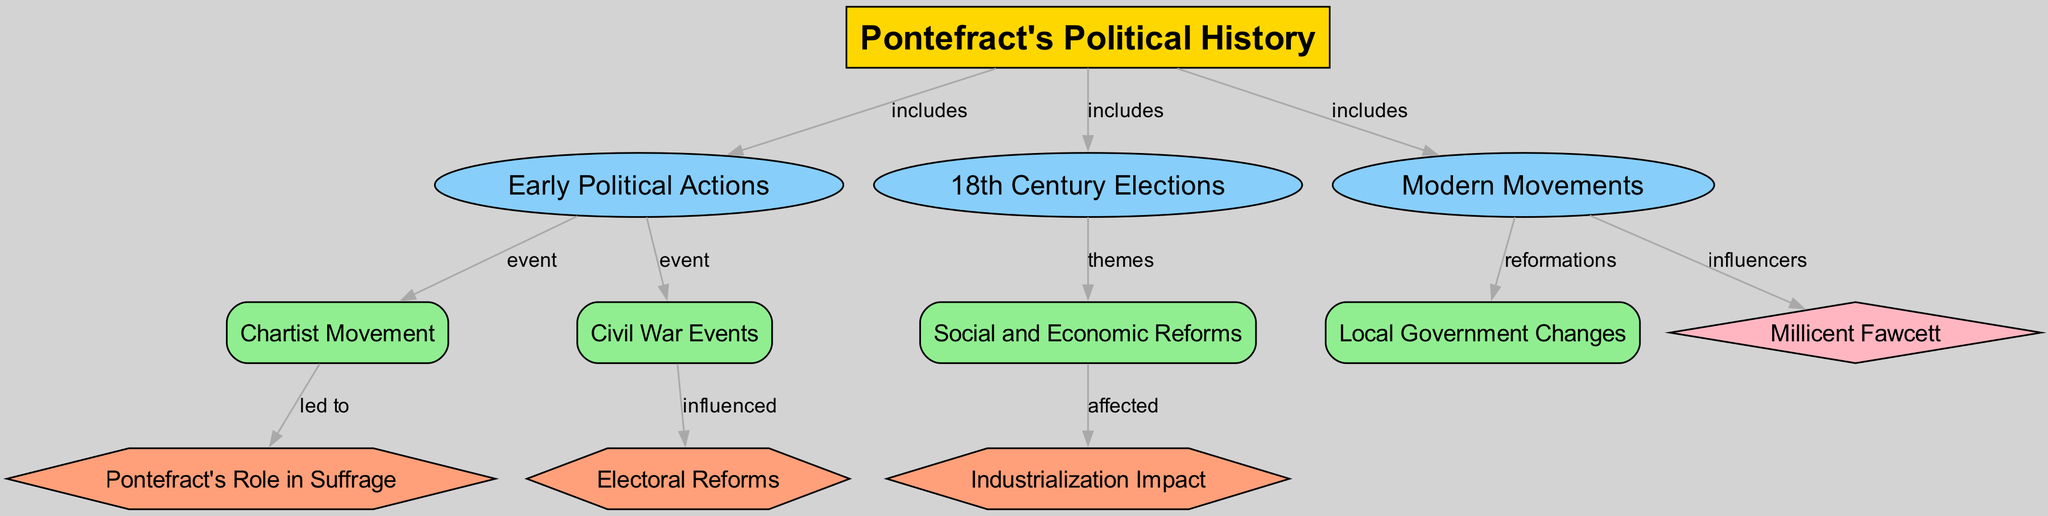What is the main title of the diagram? The main title of the diagram is provided at the top as "History and Impact of Pontefract's Political Movements."
Answer: History and Impact of Pontefract's Political Movements How many subtopics are included under Pontefract's Political History? The diagram shows three subtopics (Early Political Actions, 18th Century Elections, Modern Movements) connected to the main topic. Count them to confirm.
Answer: 3 Which political movement is associated with Millicent Fawcett? Millicent Fawcett is listed as an influencer under the "Modern Movements" subtopic, showing her impact on the women's suffrage movement.
Answer: Modern Movements What event is connected to the theme of social and economic reforms? The "Social and Economic Reforms" detail node is linked to the "Industrialization Impact" impact node, indicating that these reforms were affected by industrial changes in the area.
Answer: Industrialization Impact Which event led to changes in local government? The "Modern Movements" subtopic is directly linked to the "Local Government Changes" detail, suggesting that modern political actions influenced local governance reforms.
Answer: Local Government Changes What historical figure is specifically highlighted in the diagram? The historical figure mentioned is Millicent Fawcett, who played a significant role in the suffrage movement, emphasized as an influencer in the context of modern political movements.
Answer: Millicent Fawcett How did the Civil War events influence electoral reforms? The "Civil War Events" detail is indicated as having influenced "Electoral Reforms," meaning the outcomes or lessons from the Civil War affected how elections were structured or conducted.
Answer: Influenced What theme is associated with the 18th Century Elections? The 18th Century Elections subtopic points to "Social and Economic Reforms," showing that these elections were tied to broader themes regarding societal and economic changes of the time.
Answer: Social and Economic Reforms Which political movement connects with Pontefract's role in suffrage? The "Chartist Movement" detail is linked to "Pontefract's Role in Suffrage," indicating that the Chartist agitation played a part in advocating for voting rights and political representation.
Answer: Chartist Movement 